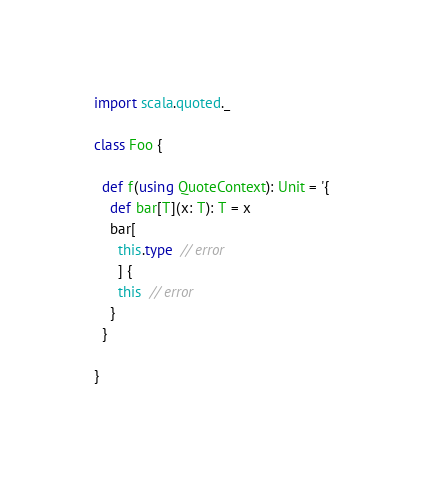Convert code to text. <code><loc_0><loc_0><loc_500><loc_500><_Scala_>import scala.quoted._

class Foo {

  def f(using QuoteContext): Unit = '{
    def bar[T](x: T): T = x
    bar[
      this.type  // error
      ] {
      this  // error
    }
  }

}
</code> 